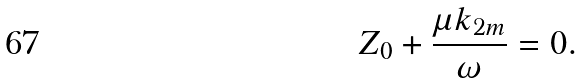Convert formula to latex. <formula><loc_0><loc_0><loc_500><loc_500>Z _ { 0 } + \frac { \mu k _ { 2 m } } { \omega } = 0 .</formula> 